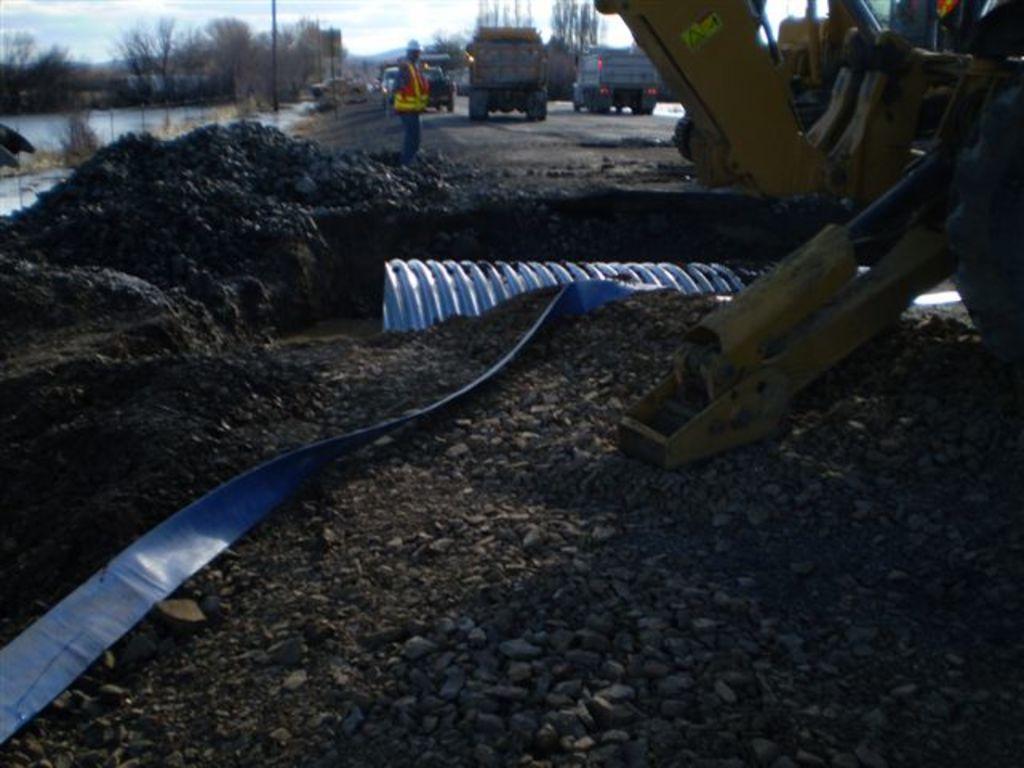In one or two sentences, can you explain what this image depicts? In this picture, we can see the ground, and some objects on the ground, we can see a few vehicles, a person, water, poles, trees and the sky with clouds. 